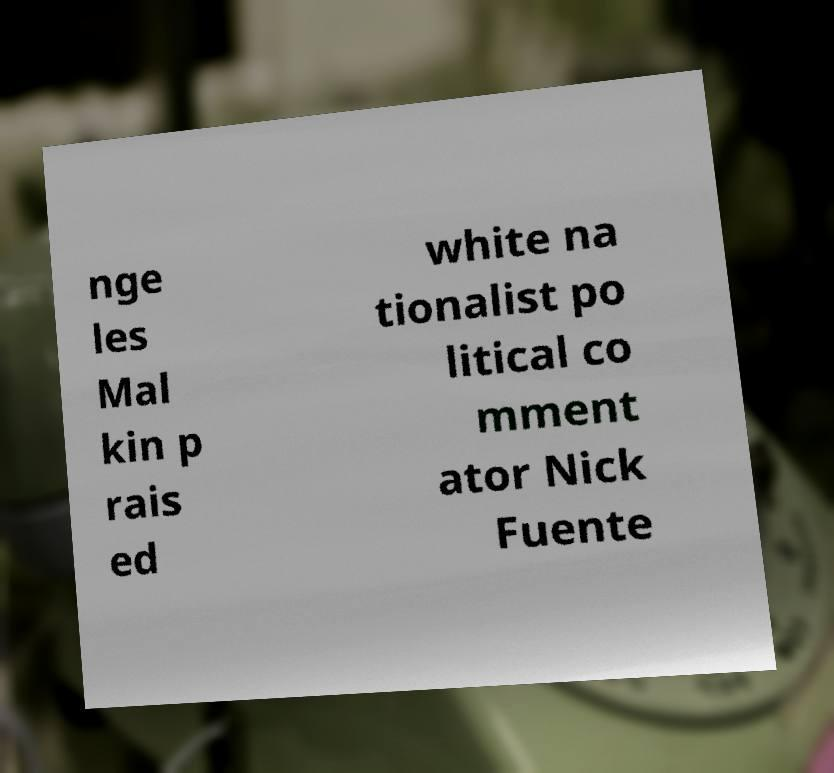Could you assist in decoding the text presented in this image and type it out clearly? nge les Mal kin p rais ed white na tionalist po litical co mment ator Nick Fuente 